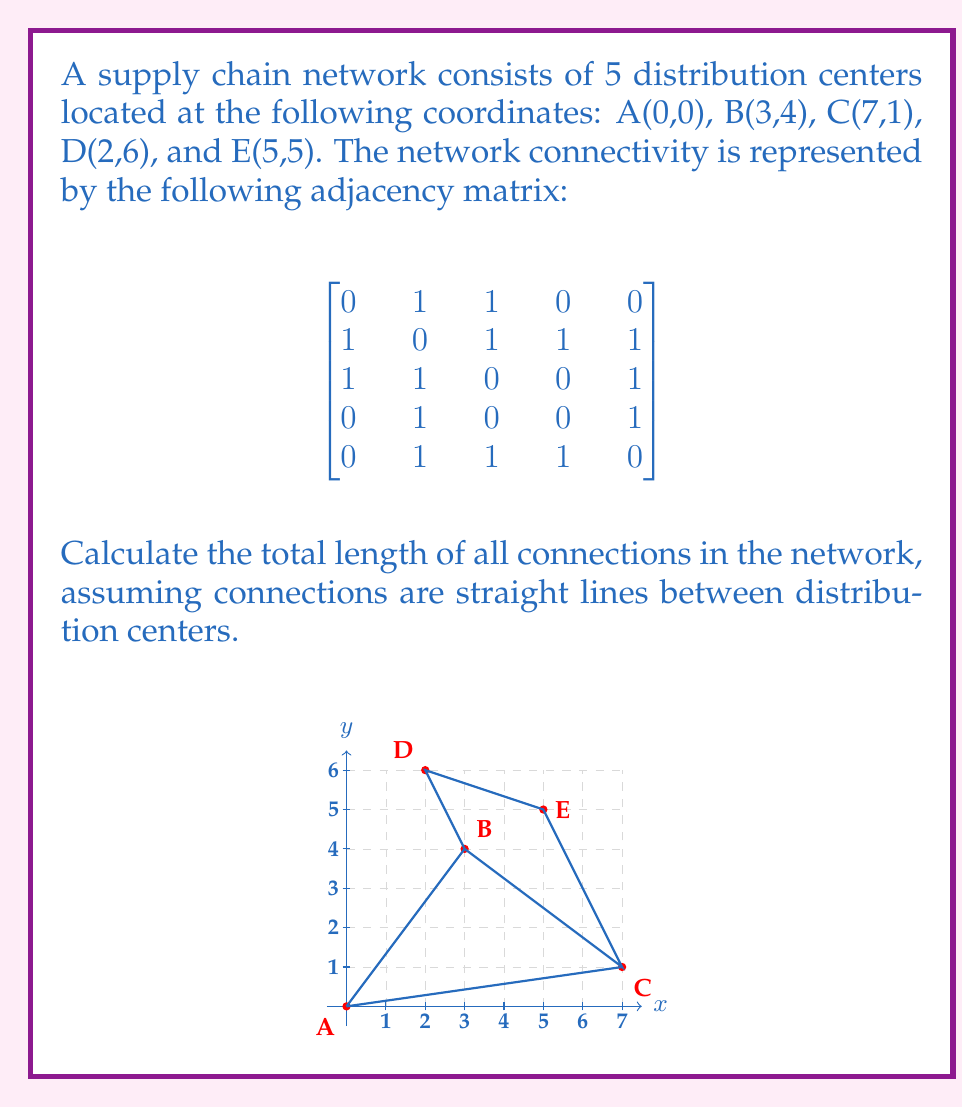Show me your answer to this math problem. To solve this problem, we'll follow these steps:

1) Identify the connections from the adjacency matrix.
2) Calculate the length of each connection using the distance formula.
3) Sum up all the lengths.

Step 1: Identifying connections
From the adjacency matrix, we can see the following connections:
A-B, A-C, B-C, B-D, B-E, C-E, D-E

Step 2: Calculating distances
We'll use the distance formula: $d = \sqrt{(x_2-x_1)^2 + (y_2-y_1)^2}$

A-B: $d_{AB} = \sqrt{(3-0)^2 + (4-0)^2} = \sqrt{9 + 16} = 5$
A-C: $d_{AC} = \sqrt{(7-0)^2 + (1-0)^2} = \sqrt{49 + 1} = \sqrt{50}$
B-C: $d_{BC} = \sqrt{(7-3)^2 + (1-4)^2} = \sqrt{16 + 9} = 5$
B-D: $d_{BD} = \sqrt{(2-3)^2 + (6-4)^2} = \sqrt{1 + 4} = \sqrt{5}$
B-E: $d_{BE} = \sqrt{(5-3)^2 + (5-4)^2} = \sqrt{4 + 1} = \sqrt{5}$
C-E: $d_{CE} = \sqrt{(5-7)^2 + (5-1)^2} = \sqrt{4 + 16} = \sqrt{20}$
D-E: $d_{DE} = \sqrt{(5-2)^2 + (5-6)^2} = \sqrt{9 + 1} = \sqrt{10}$

Step 3: Summing up all lengths
Total length = $5 + \sqrt{50} + 5 + \sqrt{5} + \sqrt{5} + \sqrt{20} + \sqrt{10}$

$= 10 + \sqrt{50} + \sqrt{5} + \sqrt{5} + \sqrt{20} + \sqrt{10}$

$= 10 + \sqrt{50} + 2\sqrt{5} + \sqrt{20} + \sqrt{10}$
Answer: $10 + \sqrt{50} + 2\sqrt{5} + \sqrt{20} + \sqrt{10}$ 